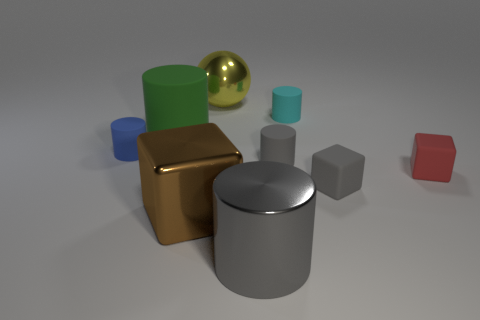Subtract all small blocks. How many blocks are left? 1 Subtract all blue cylinders. How many cylinders are left? 4 Add 1 tiny gray cylinders. How many objects exist? 10 Subtract all cyan cylinders. Subtract all green spheres. How many cylinders are left? 4 Subtract all balls. How many objects are left? 8 Add 7 tiny brown things. How many tiny brown things exist? 7 Subtract 1 red blocks. How many objects are left? 8 Subtract all purple cylinders. Subtract all tiny cyan rubber cylinders. How many objects are left? 8 Add 3 big gray objects. How many big gray objects are left? 4 